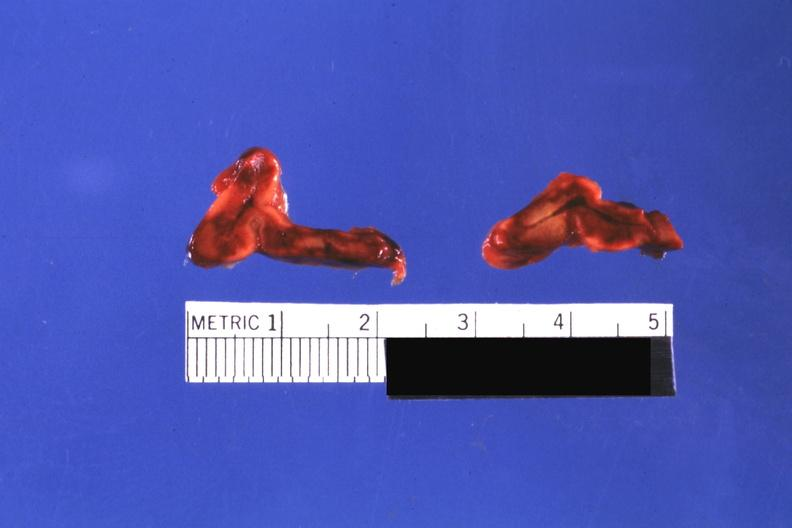do focal hemorrhagic infarction well shown not know history?
Answer the question using a single word or phrase. Yes 